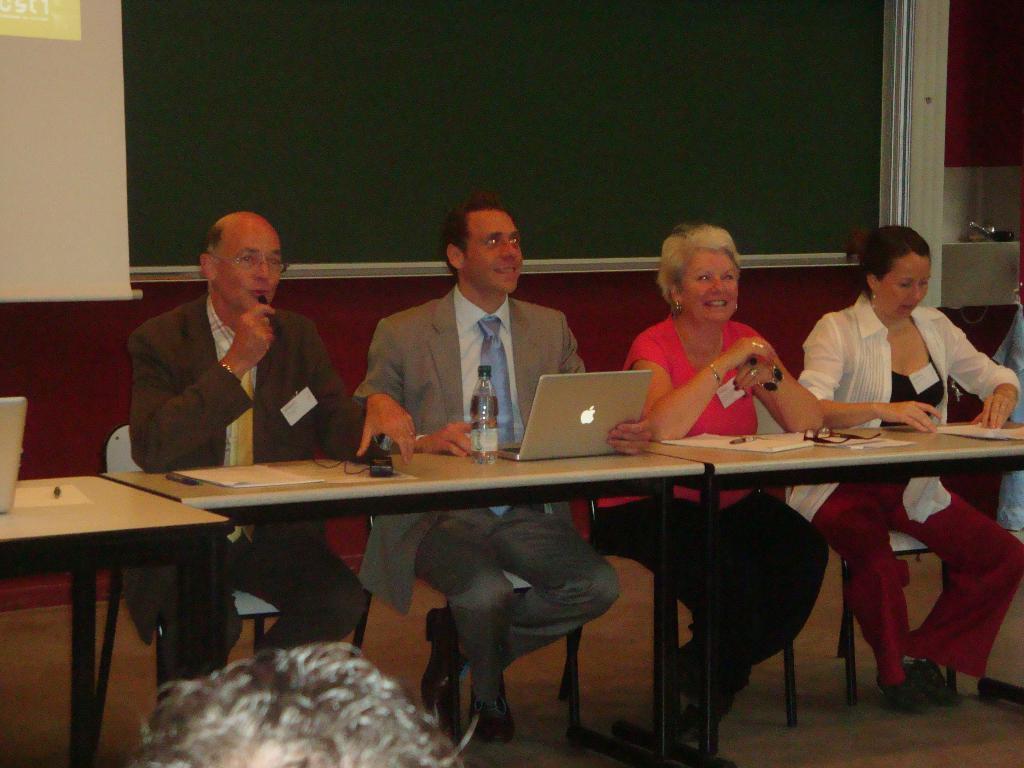Describe this image in one or two sentences. In this image we can see four people are sitting on the chairs near the table. There are water bottle, laptop, spectacles and papers on the table. 